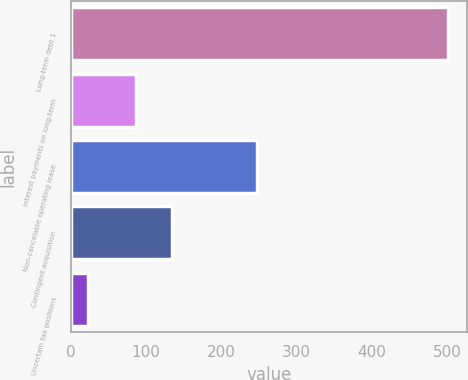Convert chart. <chart><loc_0><loc_0><loc_500><loc_500><bar_chart><fcel>Long-term debt 1<fcel>Interest payments on long-term<fcel>Non-cancelable operating lease<fcel>Contingent acquisition<fcel>Uncertain tax positions<nl><fcel>501.4<fcel>86.7<fcel>247.6<fcel>134.49<fcel>23.5<nl></chart> 